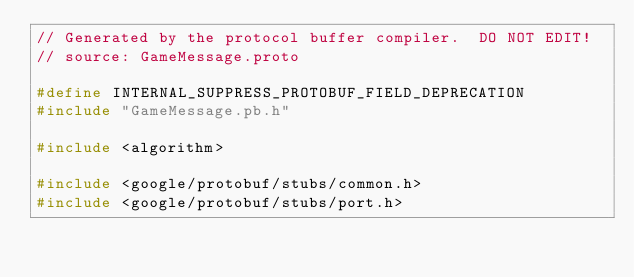Convert code to text. <code><loc_0><loc_0><loc_500><loc_500><_C++_>// Generated by the protocol buffer compiler.  DO NOT EDIT!
// source: GameMessage.proto

#define INTERNAL_SUPPRESS_PROTOBUF_FIELD_DEPRECATION
#include "GameMessage.pb.h"

#include <algorithm>

#include <google/protobuf/stubs/common.h>
#include <google/protobuf/stubs/port.h></code> 